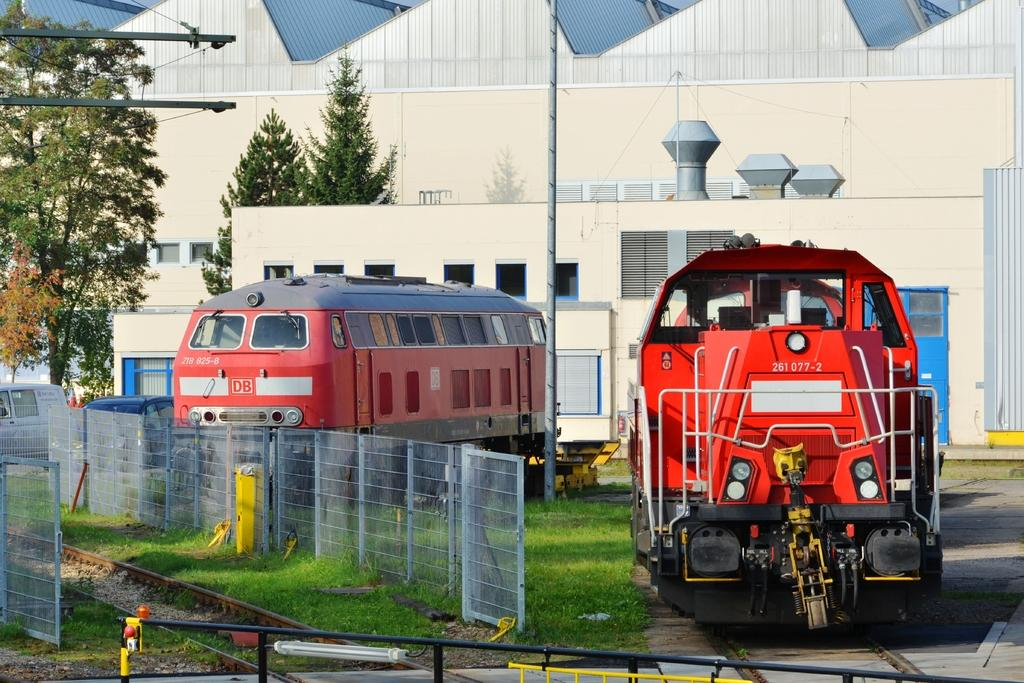What is happening on the road in the image? There are vehicles on the road in the image. What is in front of the vehicles? There is a metal fencing in front of the vehicles. What can be seen in the background of the image? There are trees and buildings in the background of the image. How much debt is the rabbit carrying in the image? There is no rabbit present in the image, and therefore no debt can be associated with it. What type of toy can be seen in the image? There is no toy present in the image. 